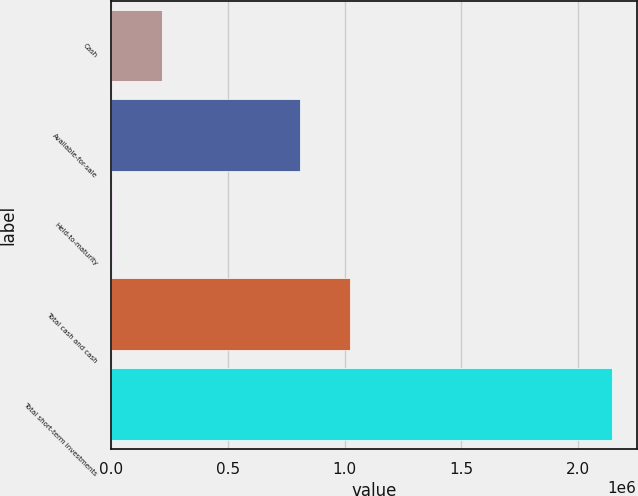Convert chart. <chart><loc_0><loc_0><loc_500><loc_500><bar_chart><fcel>Cash<fcel>Available-for-sale<fcel>Held-to-maturity<fcel>Total cash and cash<fcel>Total short-term investments<nl><fcel>217860<fcel>807935<fcel>3780<fcel>1.02201e+06<fcel>2.14458e+06<nl></chart> 